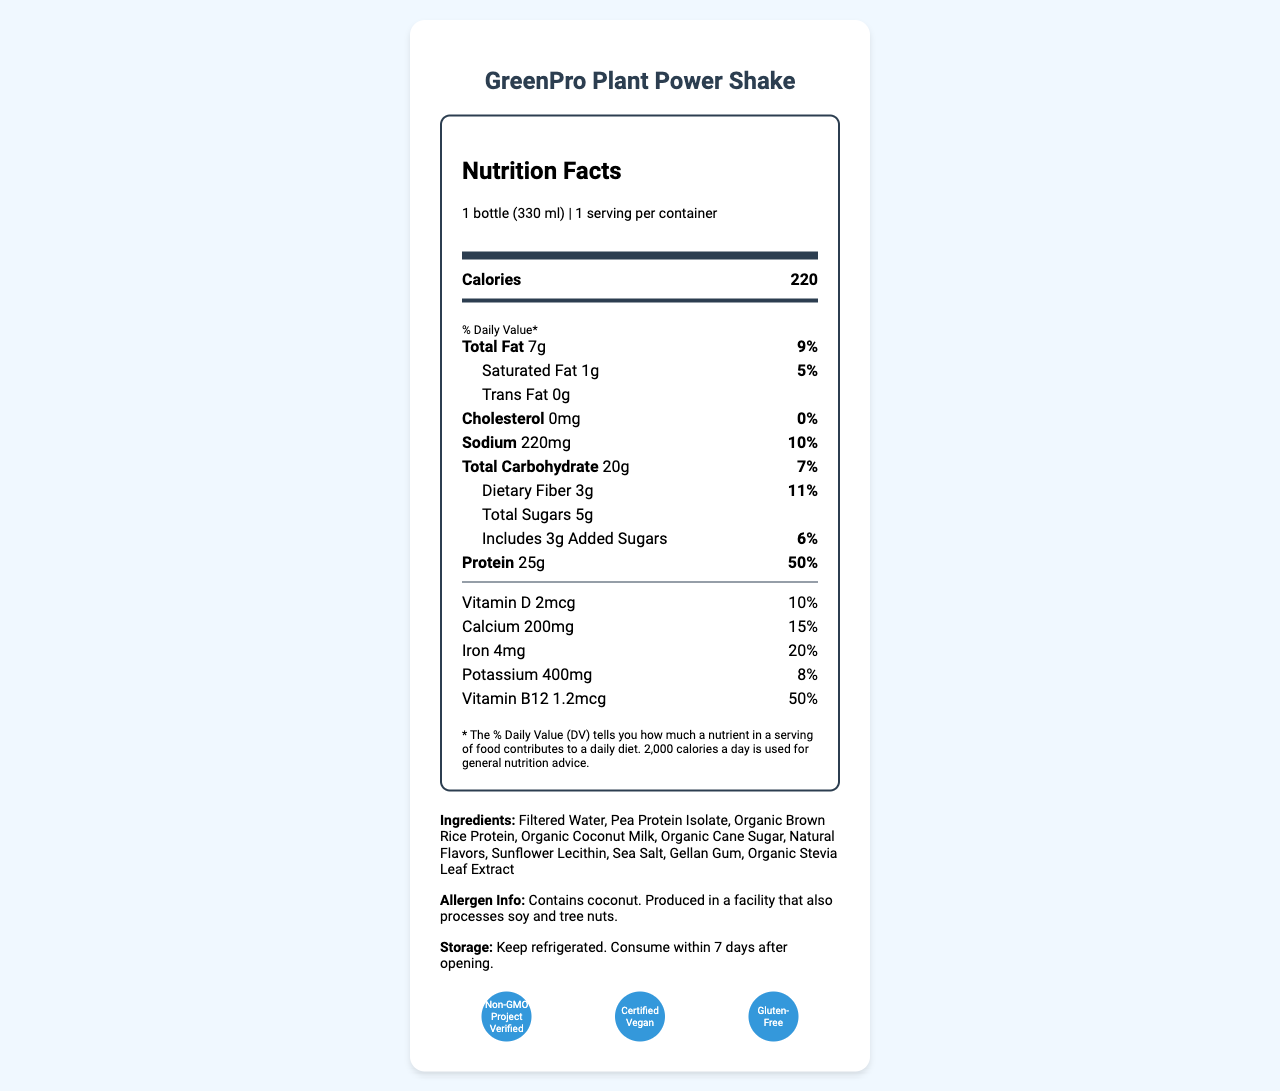what is the total fat content per serving? The total fat content per serving is displayed as "Total Fat 7g" in the nutrient breakdown.
Answer: 7g how much protein does one serving contain? The amount of protein per serving is indicated as "Protein 25g".
Answer: 25g what percent of the daily value does the dietary fiber content represent? The dietary fiber content and its daily value percentage are shown as "Dietary Fiber 3g 11%".
Answer: 11% what certifications does the product have? The certifications are listed at the bottom of the document under "certifications".
Answer: Non-GMO Project Verified, Certified Vegan, Gluten-Free how should the product be stored? The storage instructions are provided under "Storage".
Answer: Keep refrigerated. Consume within 7 days after opening. what is the serving size? A. 330 ml B. 1 bottle C. 2 servings D. Both A and B The serving size is indicated as "1 bottle (330 ml)".
Answer: D. Both A and B how much calcium is present per serving? A. 10mg B. 100mg C. 200mg D. 400mg The amount of calcium per serving is listed as "Calcium 200mg".
Answer: C. 200mg is the product free from cholesterol? The document specifies that there is "Cholesterol 0mg" with a 0% daily value.
Answer: Yes does the product contain any allergens? The allergen information indicates that the product "Contains coconut. Produced in a facility that also processes soy and tree nuts."
Answer: Yes what nutrients contribute to the protein content being 50% of the daily value? The only nutrient listed that directly contributes to the 50% daily value is protein, as detailed in the nutrient breakdown.
Answer: Protein could the product be suitable for health-conscious consumers? Why or why not? The document lists "health-conscious consumers" as part of the target audience in the digital library metadata, and the nutrient breakdown shows it is low in cholesterol and trans fat, with a significant protein content.
Answer: Yes what additional resources are related to this product? The related resources are shown in the digital library metadata section under "related resources".
Answer: Plant-based Nutrition Guide, Protein Requirements for Athletes, Vegan Recipe Collection what is the primary ingredient in this product? The first ingredient listed is "Filtered Water", indicating it is the primary ingredient.
Answer: Filtered Water does the product have added sugars? The nutrient breakdown notes "Includes 3g Added Sugars".
Answer: Yes what percentage of the daily value for iron does the product provide? It is indicated in the nutrient breakdown that the iron content contributes to "20%" of the daily value.
Answer: 20% can you determine the product's price from the document? The document does not provide any information about the price of the product.
Answer: Not enough information 